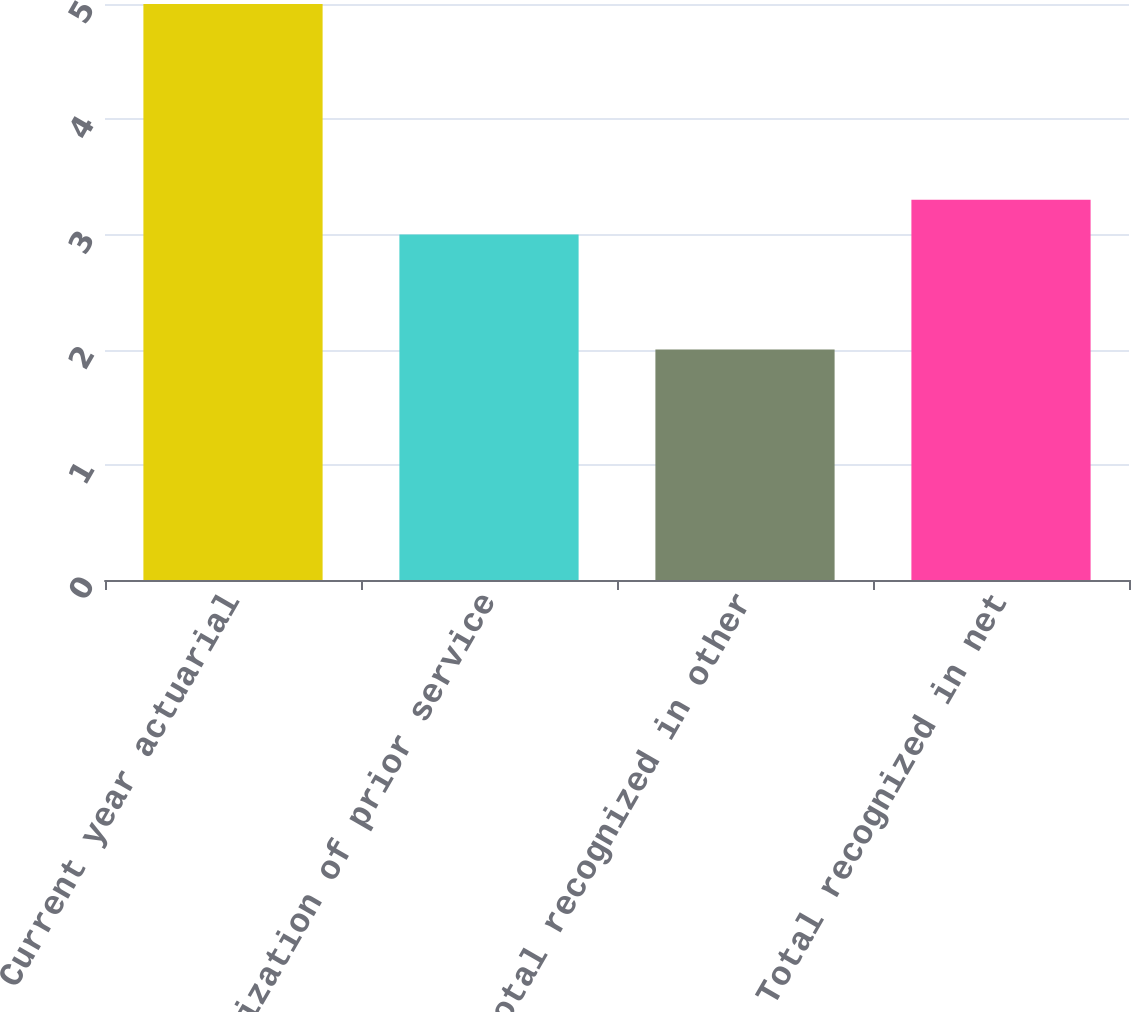Convert chart to OTSL. <chart><loc_0><loc_0><loc_500><loc_500><bar_chart><fcel>Current year actuarial<fcel>Amortization of prior service<fcel>Total recognized in other<fcel>Total recognized in net<nl><fcel>5<fcel>3<fcel>2<fcel>3.3<nl></chart> 